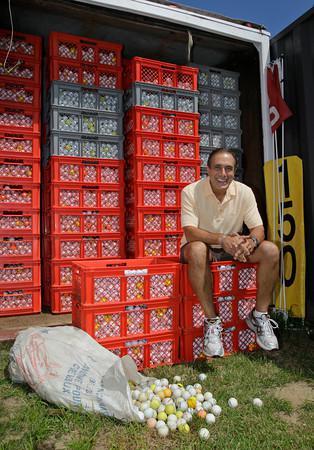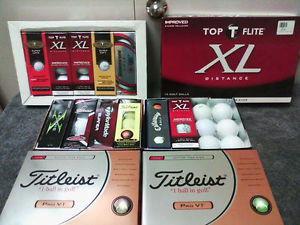The first image is the image on the left, the second image is the image on the right. For the images shown, is this caption "A person is sitting by golf balls in one of the images." true? Answer yes or no. Yes. 